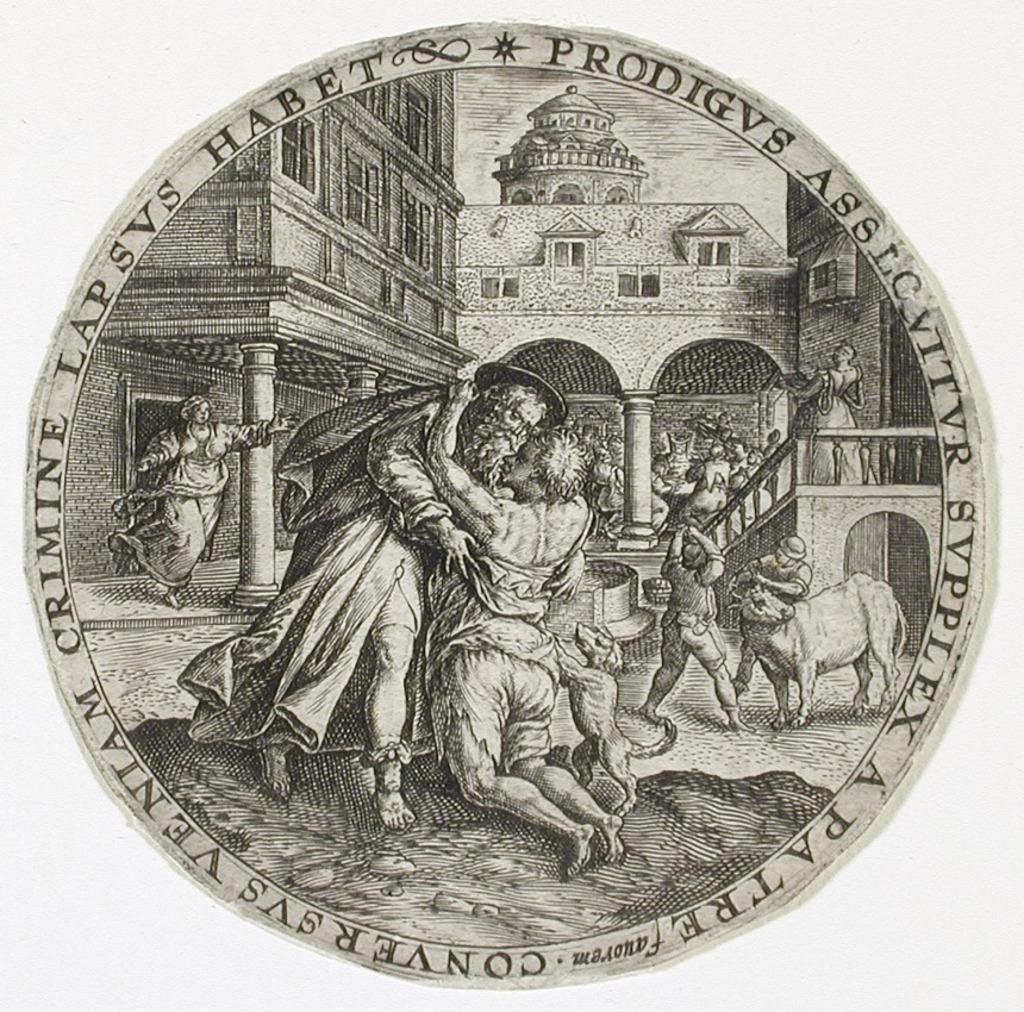What is present in the image that has a specific shape? There is a poster in the image, and it is circular in shape. Can you describe the poster in more detail? Unfortunately, the provided facts do not give any additional details about the poster. What type of coat is hanging on the sea in the image? There is no coat or sea present in the image; it only features a circular poster. 